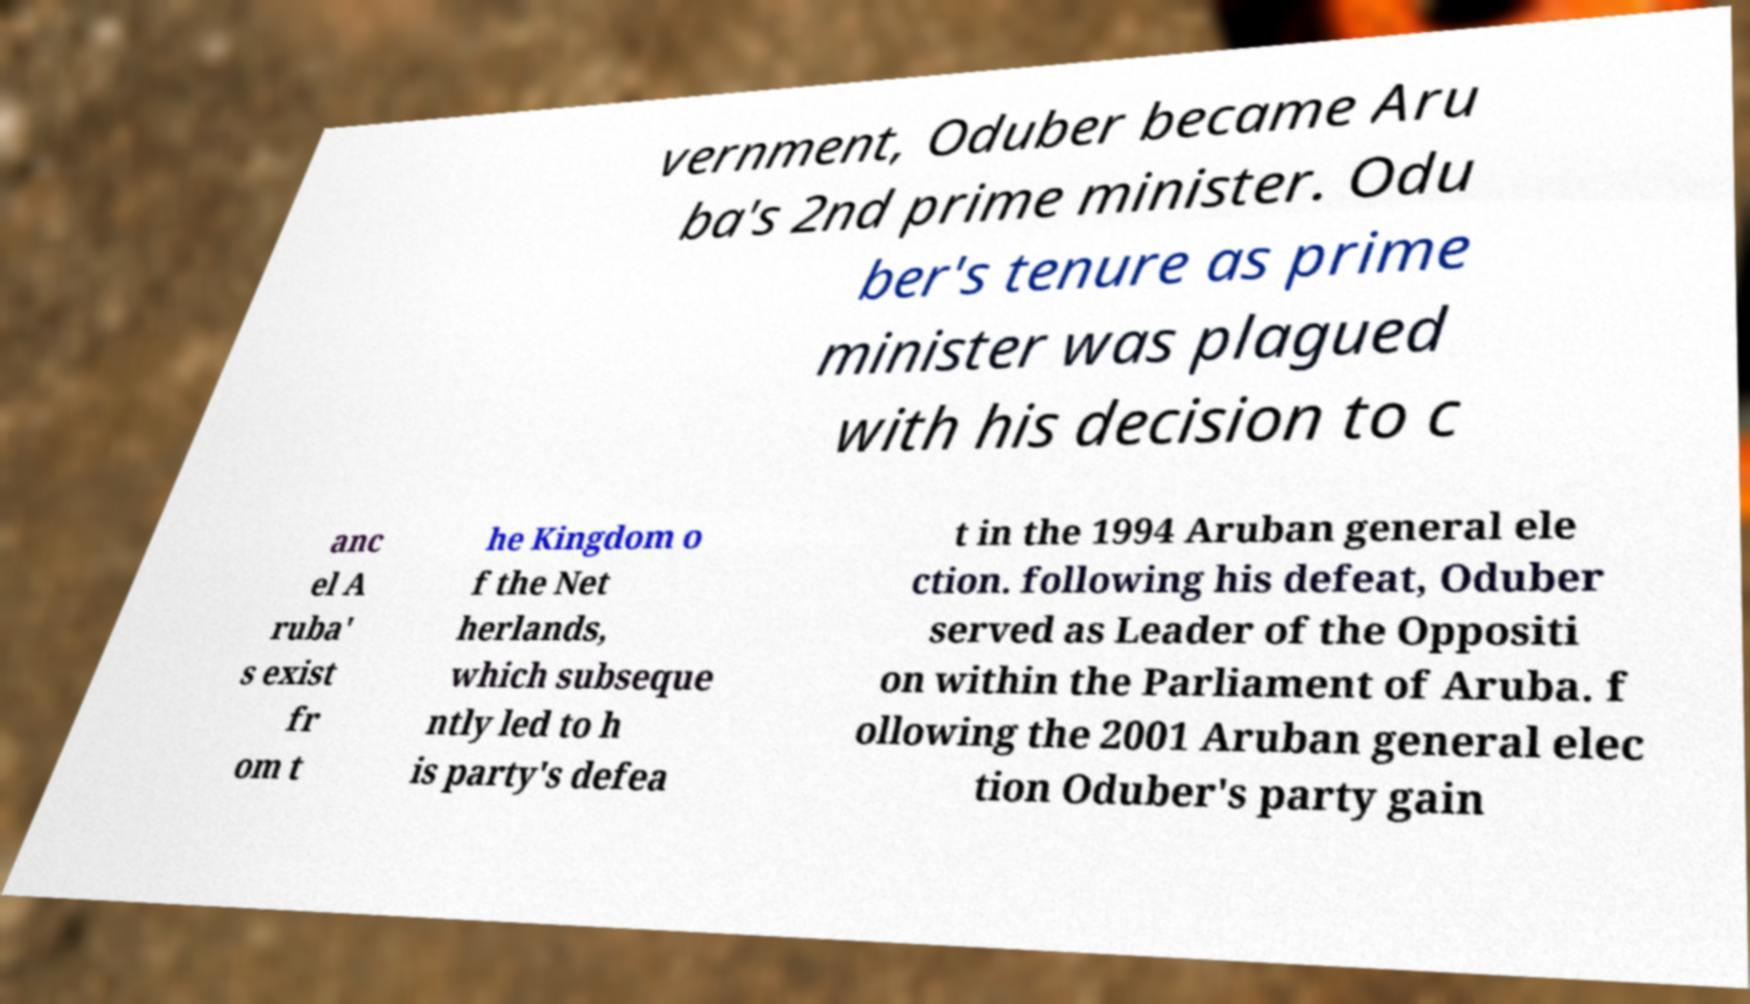What messages or text are displayed in this image? I need them in a readable, typed format. vernment, Oduber became Aru ba's 2nd prime minister. Odu ber's tenure as prime minister was plagued with his decision to c anc el A ruba' s exist fr om t he Kingdom o f the Net herlands, which subseque ntly led to h is party's defea t in the 1994 Aruban general ele ction. following his defeat, Oduber served as Leader of the Oppositi on within the Parliament of Aruba. f ollowing the 2001 Aruban general elec tion Oduber's party gain 